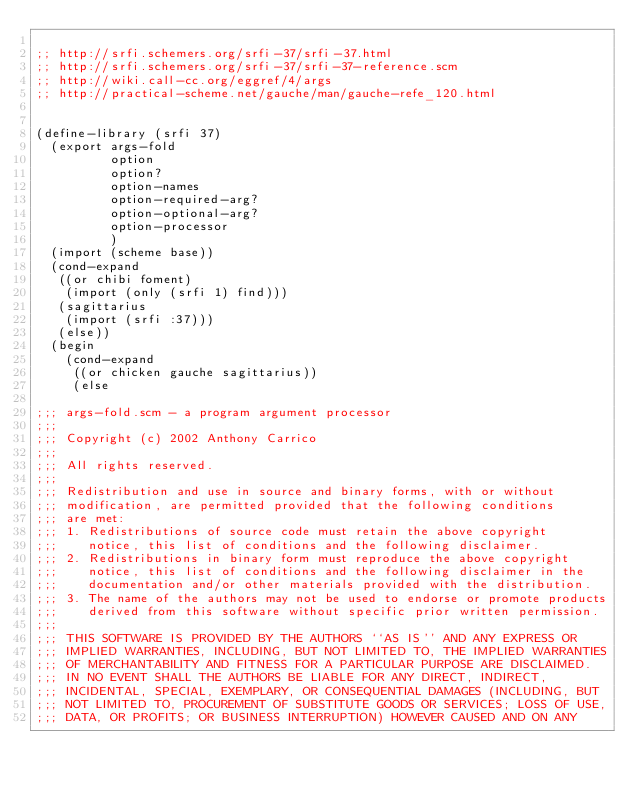Convert code to text. <code><loc_0><loc_0><loc_500><loc_500><_Scheme_>
;; http://srfi.schemers.org/srfi-37/srfi-37.html
;; http://srfi.schemers.org/srfi-37/srfi-37-reference.scm
;; http://wiki.call-cc.org/eggref/4/args
;; http://practical-scheme.net/gauche/man/gauche-refe_120.html


(define-library (srfi 37)
  (export args-fold
          option
          option?
          option-names
          option-required-arg?
          option-optional-arg?
          option-processor
          )
  (import (scheme base))
  (cond-expand
   ((or chibi foment)
    (import (only (srfi 1) find)))
   (sagittarius
    (import (srfi :37)))
   (else))
  (begin
    (cond-expand
     ((or chicken gauche sagittarius))
     (else

;;; args-fold.scm - a program argument processor
;;;
;;; Copyright (c) 2002 Anthony Carrico
;;;
;;; All rights reserved.
;;;
;;; Redistribution and use in source and binary forms, with or without
;;; modification, are permitted provided that the following conditions
;;; are met:
;;; 1. Redistributions of source code must retain the above copyright
;;;    notice, this list of conditions and the following disclaimer.
;;; 2. Redistributions in binary form must reproduce the above copyright
;;;    notice, this list of conditions and the following disclaimer in the
;;;    documentation and/or other materials provided with the distribution.
;;; 3. The name of the authors may not be used to endorse or promote products
;;;    derived from this software without specific prior written permission.
;;;
;;; THIS SOFTWARE IS PROVIDED BY THE AUTHORS ``AS IS'' AND ANY EXPRESS OR
;;; IMPLIED WARRANTIES, INCLUDING, BUT NOT LIMITED TO, THE IMPLIED WARRANTIES
;;; OF MERCHANTABILITY AND FITNESS FOR A PARTICULAR PURPOSE ARE DISCLAIMED.
;;; IN NO EVENT SHALL THE AUTHORS BE LIABLE FOR ANY DIRECT, INDIRECT,
;;; INCIDENTAL, SPECIAL, EXEMPLARY, OR CONSEQUENTIAL DAMAGES (INCLUDING, BUT
;;; NOT LIMITED TO, PROCUREMENT OF SUBSTITUTE GOODS OR SERVICES; LOSS OF USE,
;;; DATA, OR PROFITS; OR BUSINESS INTERRUPTION) HOWEVER CAUSED AND ON ANY</code> 